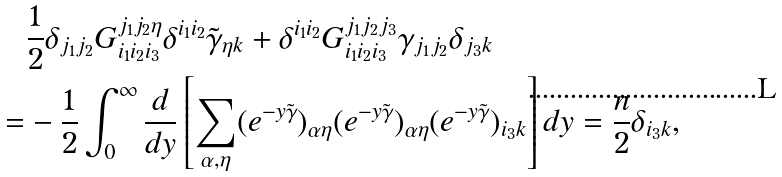<formula> <loc_0><loc_0><loc_500><loc_500>& \frac { 1 } { 2 } \delta _ { j _ { 1 } j _ { 2 } } G _ { i _ { 1 } i _ { 2 } i _ { 3 } } ^ { j _ { 1 } j _ { 2 } \eta } \delta ^ { i _ { 1 } i _ { 2 } } \tilde { \gamma } _ { \eta k } + \delta ^ { i _ { 1 } i _ { 2 } } G _ { i _ { 1 } i _ { 2 } i _ { 3 } } ^ { j _ { 1 } j _ { 2 } j _ { 3 } } \gamma _ { j _ { 1 } j _ { 2 } } \delta _ { j _ { 3 } k } \\ = & - \frac { 1 } { 2 } \int _ { 0 } ^ { \infty } \frac { d } { d y } \left [ \sum _ { \alpha , \eta } ( e ^ { - y \tilde { \gamma } } ) _ { \alpha \eta } ( e ^ { - y \tilde { \gamma } } ) _ { \alpha \eta } ( e ^ { - y \tilde { \gamma } } ) _ { i _ { 3 } k } \right ] d y = \frac { n } { 2 } \delta _ { i _ { 3 } k } ,</formula> 